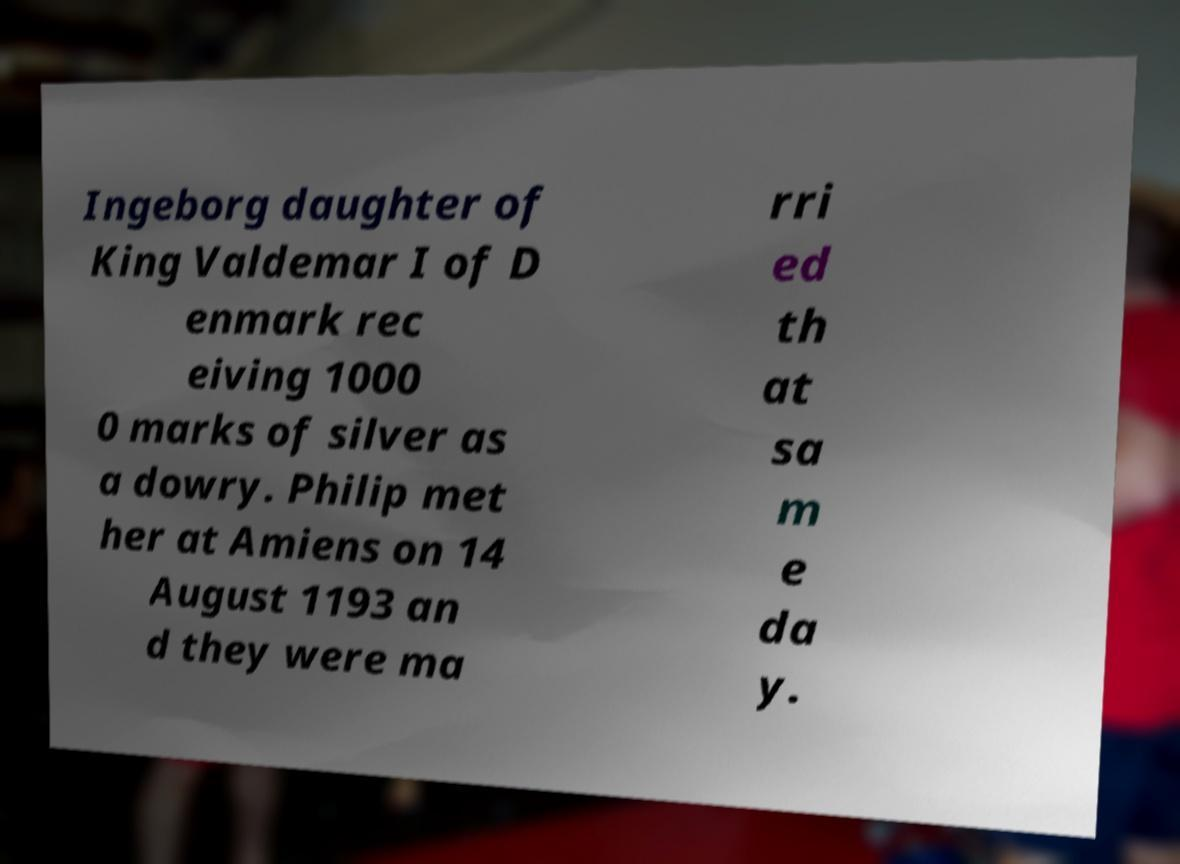Please read and relay the text visible in this image. What does it say? Ingeborg daughter of King Valdemar I of D enmark rec eiving 1000 0 marks of silver as a dowry. Philip met her at Amiens on 14 August 1193 an d they were ma rri ed th at sa m e da y. 